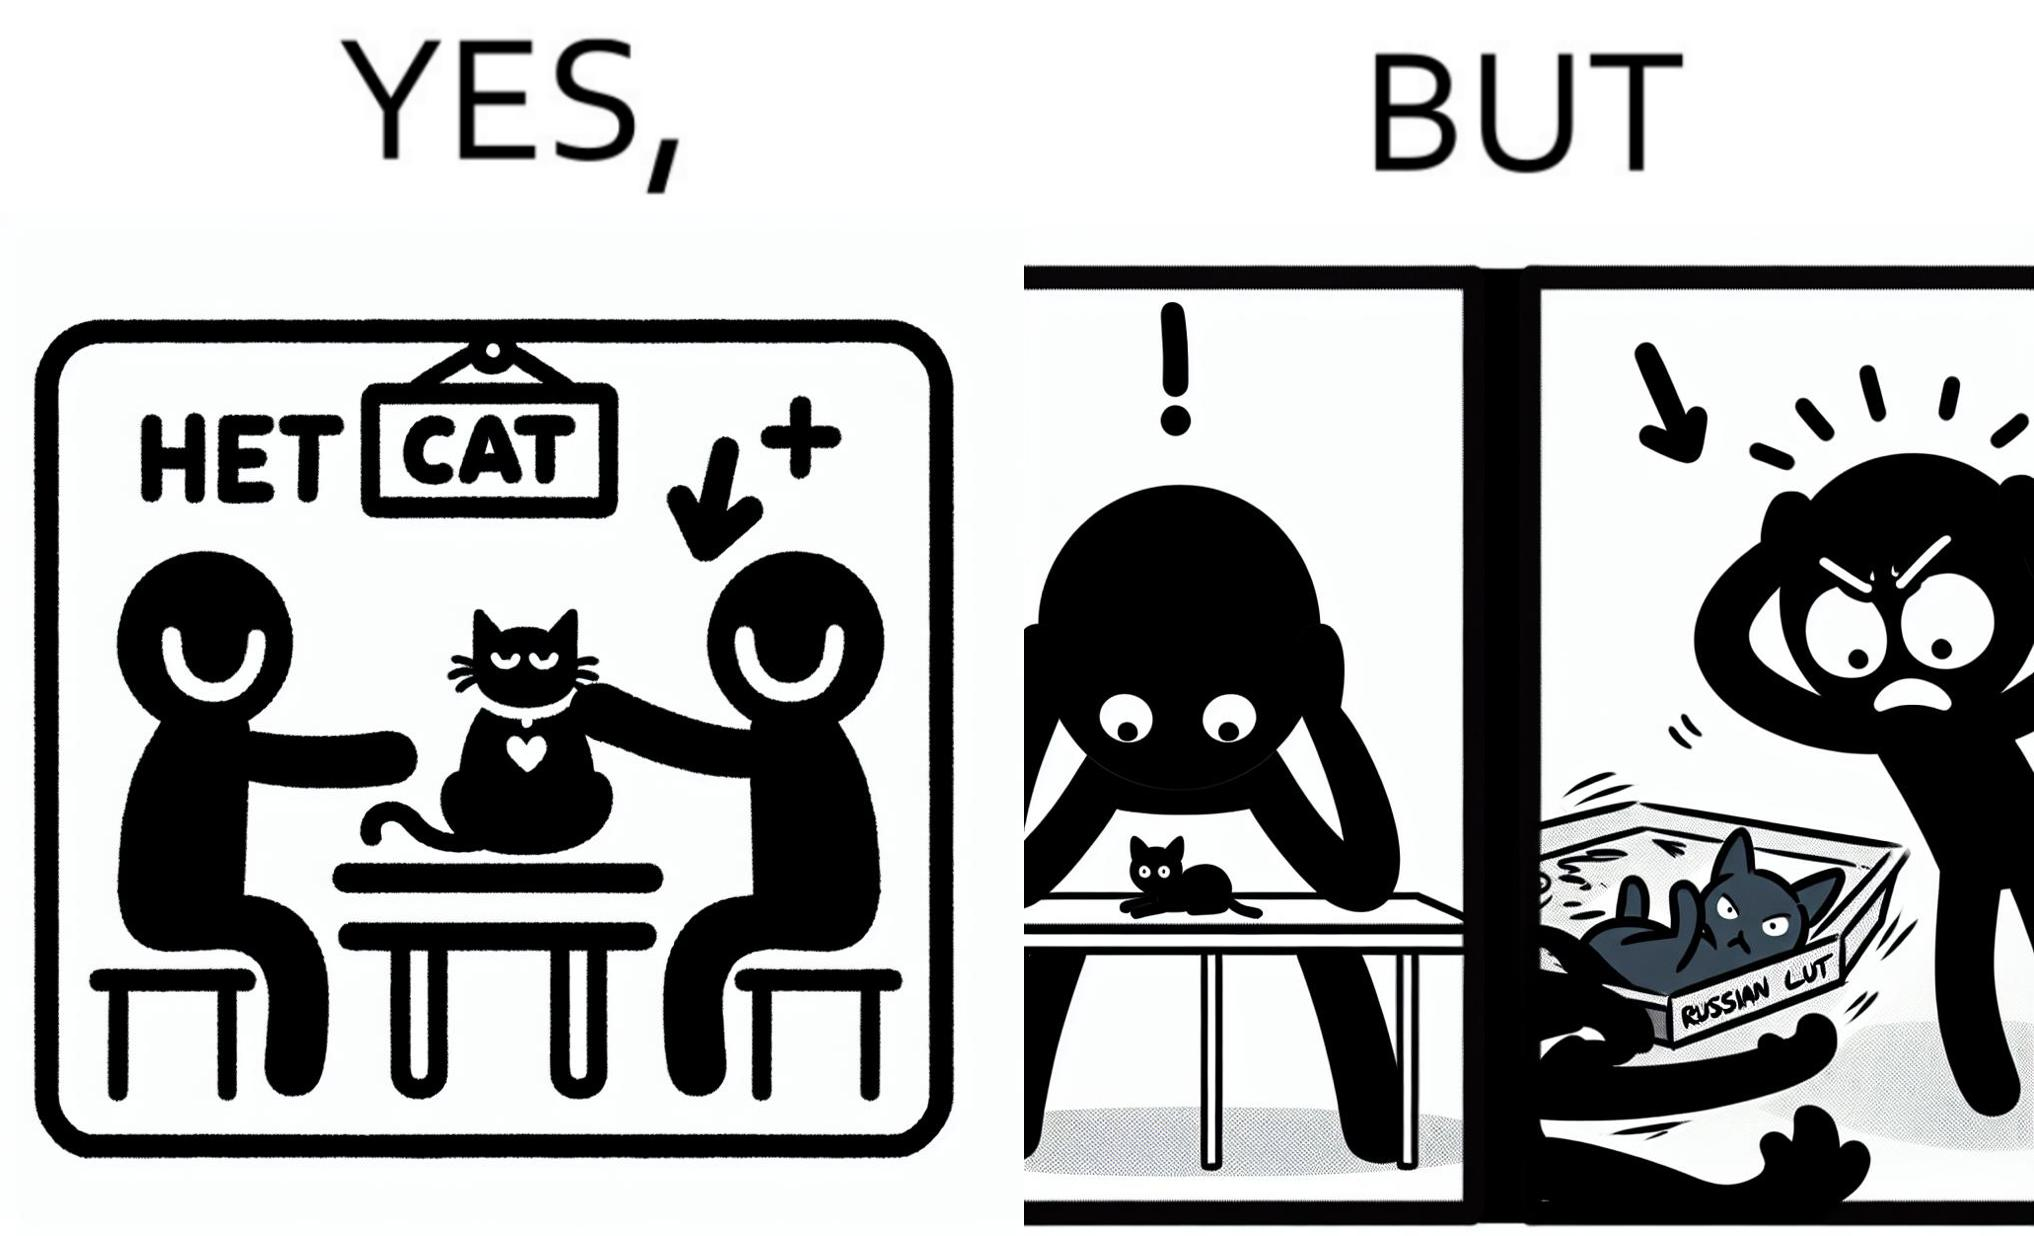Is there satirical content in this image? Yes, this image is satirical. 